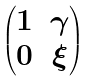Convert formula to latex. <formula><loc_0><loc_0><loc_500><loc_500>\begin{pmatrix} 1 & \gamma \\ 0 & \xi \end{pmatrix}</formula> 